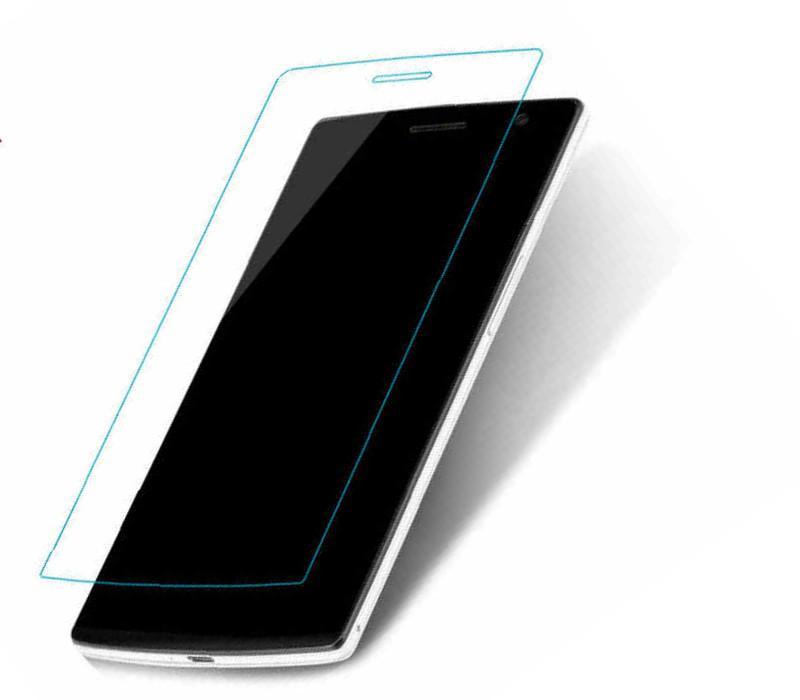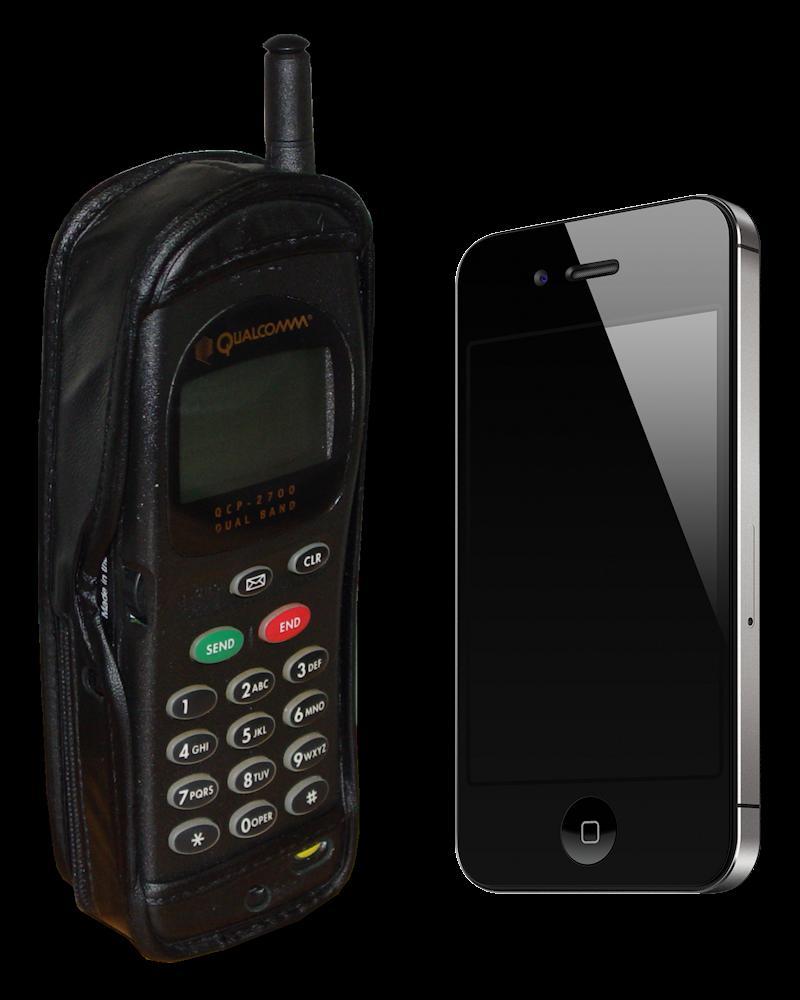The first image is the image on the left, the second image is the image on the right. Evaluate the accuracy of this statement regarding the images: "In one of the images you can see a screen protector being applied to the front of a smartphone.". Is it true? Answer yes or no. Yes. The first image is the image on the left, the second image is the image on the right. Analyze the images presented: Is the assertion "The image on the left shows a screen protector hovering over a phone." valid? Answer yes or no. Yes. 